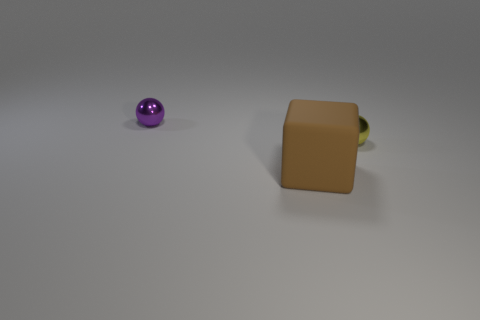What number of metal objects are small yellow spheres or purple spheres?
Your answer should be compact. 2. Is the number of small yellow objects that are on the left side of the brown rubber thing greater than the number of purple things that are behind the purple thing?
Offer a terse response. No. How many other things are the same size as the purple metal ball?
Offer a terse response. 1. What size is the ball that is on the left side of the metallic thing to the right of the large brown matte cube?
Your response must be concise. Small. What number of big things are metal balls or blue shiny things?
Your answer should be very brief. 0. What is the size of the metallic object to the right of the tiny metallic thing that is to the left of the metallic sphere that is right of the rubber object?
Make the answer very short. Small. Are there any other things that are the same color as the matte thing?
Your answer should be very brief. No. There is a tiny purple object behind the object in front of the yellow shiny thing in front of the purple metal thing; what is its material?
Provide a succinct answer. Metal. Does the big brown thing have the same shape as the yellow metal thing?
Make the answer very short. No. Is there any other thing that is the same material as the brown object?
Offer a very short reply. No. 